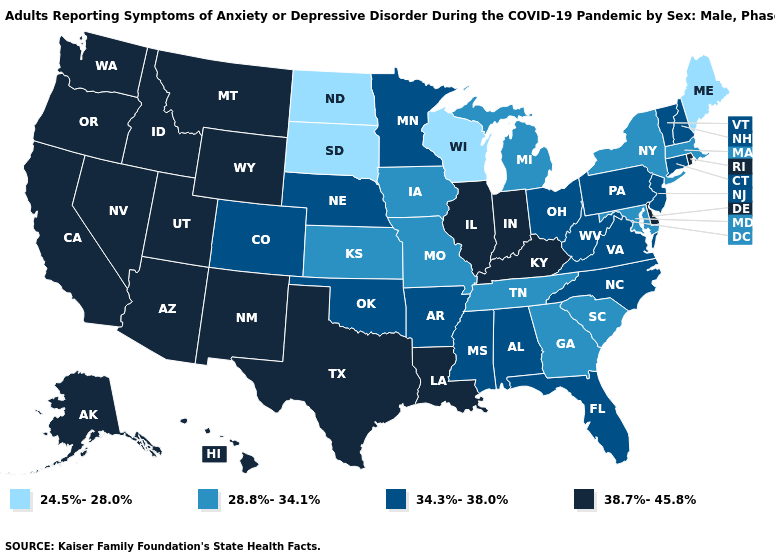Is the legend a continuous bar?
Concise answer only. No. Name the states that have a value in the range 38.7%-45.8%?
Answer briefly. Alaska, Arizona, California, Delaware, Hawaii, Idaho, Illinois, Indiana, Kentucky, Louisiana, Montana, Nevada, New Mexico, Oregon, Rhode Island, Texas, Utah, Washington, Wyoming. Among the states that border Texas , which have the highest value?
Short answer required. Louisiana, New Mexico. Among the states that border Montana , does South Dakota have the highest value?
Be succinct. No. Does Virginia have the same value as Alabama?
Write a very short answer. Yes. Does South Dakota have the highest value in the MidWest?
Keep it brief. No. Among the states that border Louisiana , does Arkansas have the highest value?
Write a very short answer. No. What is the value of Maine?
Concise answer only. 24.5%-28.0%. Among the states that border New Mexico , which have the highest value?
Be succinct. Arizona, Texas, Utah. Name the states that have a value in the range 34.3%-38.0%?
Answer briefly. Alabama, Arkansas, Colorado, Connecticut, Florida, Minnesota, Mississippi, Nebraska, New Hampshire, New Jersey, North Carolina, Ohio, Oklahoma, Pennsylvania, Vermont, Virginia, West Virginia. Name the states that have a value in the range 24.5%-28.0%?
Short answer required. Maine, North Dakota, South Dakota, Wisconsin. Name the states that have a value in the range 34.3%-38.0%?
Write a very short answer. Alabama, Arkansas, Colorado, Connecticut, Florida, Minnesota, Mississippi, Nebraska, New Hampshire, New Jersey, North Carolina, Ohio, Oklahoma, Pennsylvania, Vermont, Virginia, West Virginia. What is the value of Vermont?
Concise answer only. 34.3%-38.0%. What is the value of Montana?
Answer briefly. 38.7%-45.8%. 